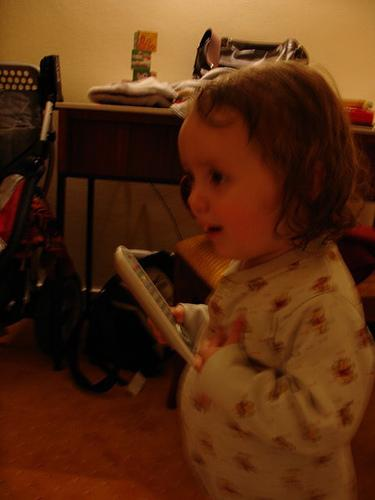Judging by the childs hair what did they just get done with? bath 